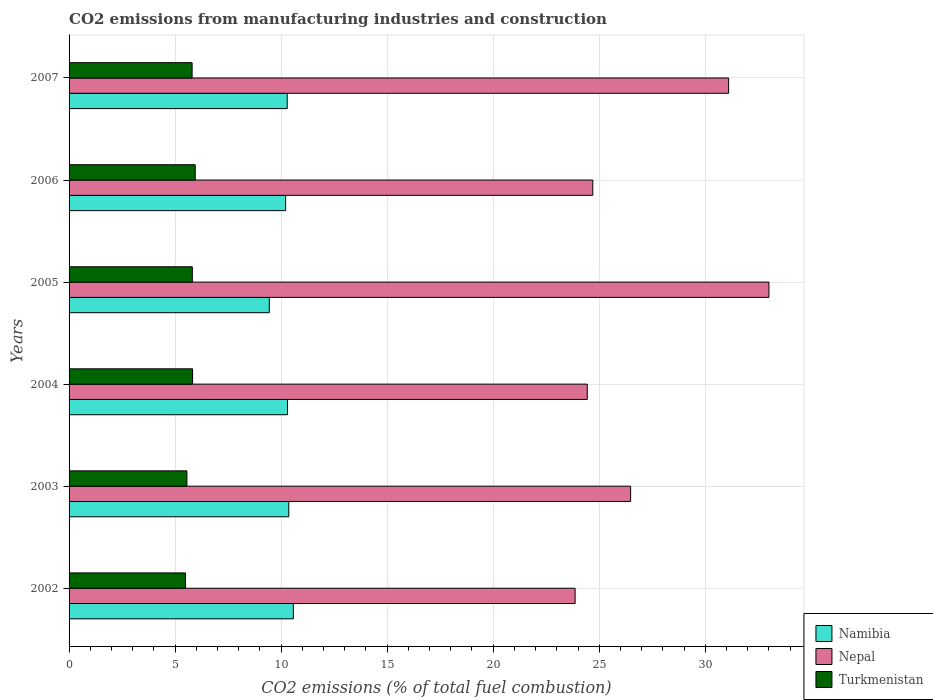Are the number of bars per tick equal to the number of legend labels?
Give a very brief answer. Yes. What is the label of the 4th group of bars from the top?
Your answer should be compact. 2004. What is the amount of CO2 emitted in Nepal in 2004?
Your answer should be compact. 24.44. Across all years, what is the maximum amount of CO2 emitted in Nepal?
Your answer should be compact. 33. Across all years, what is the minimum amount of CO2 emitted in Nepal?
Make the answer very short. 23.86. In which year was the amount of CO2 emitted in Namibia maximum?
Give a very brief answer. 2002. In which year was the amount of CO2 emitted in Nepal minimum?
Ensure brevity in your answer.  2002. What is the total amount of CO2 emitted in Turkmenistan in the graph?
Give a very brief answer. 34.44. What is the difference between the amount of CO2 emitted in Namibia in 2002 and that in 2004?
Give a very brief answer. 0.28. What is the difference between the amount of CO2 emitted in Turkmenistan in 2006 and the amount of CO2 emitted in Namibia in 2007?
Offer a terse response. -4.34. What is the average amount of CO2 emitted in Turkmenistan per year?
Give a very brief answer. 5.74. In the year 2002, what is the difference between the amount of CO2 emitted in Namibia and amount of CO2 emitted in Turkmenistan?
Your response must be concise. 5.08. What is the ratio of the amount of CO2 emitted in Namibia in 2004 to that in 2006?
Provide a succinct answer. 1.01. What is the difference between the highest and the second highest amount of CO2 emitted in Nepal?
Provide a succinct answer. 1.9. What is the difference between the highest and the lowest amount of CO2 emitted in Turkmenistan?
Your response must be concise. 0.46. What does the 1st bar from the top in 2005 represents?
Ensure brevity in your answer.  Turkmenistan. What does the 2nd bar from the bottom in 2003 represents?
Provide a succinct answer. Nepal. Is it the case that in every year, the sum of the amount of CO2 emitted in Turkmenistan and amount of CO2 emitted in Nepal is greater than the amount of CO2 emitted in Namibia?
Provide a short and direct response. Yes. Are all the bars in the graph horizontal?
Provide a short and direct response. Yes. How many years are there in the graph?
Keep it short and to the point. 6. What is the difference between two consecutive major ticks on the X-axis?
Give a very brief answer. 5. Are the values on the major ticks of X-axis written in scientific E-notation?
Provide a succinct answer. No. Does the graph contain grids?
Offer a very short reply. Yes. Where does the legend appear in the graph?
Your answer should be very brief. Bottom right. What is the title of the graph?
Provide a short and direct response. CO2 emissions from manufacturing industries and construction. Does "Monaco" appear as one of the legend labels in the graph?
Give a very brief answer. No. What is the label or title of the X-axis?
Your answer should be compact. CO2 emissions (% of total fuel combustion). What is the CO2 emissions (% of total fuel combustion) in Namibia in 2002?
Offer a very short reply. 10.58. What is the CO2 emissions (% of total fuel combustion) of Nepal in 2002?
Give a very brief answer. 23.86. What is the CO2 emissions (% of total fuel combustion) of Turkmenistan in 2002?
Give a very brief answer. 5.49. What is the CO2 emissions (% of total fuel combustion) in Namibia in 2003?
Make the answer very short. 10.36. What is the CO2 emissions (% of total fuel combustion) in Nepal in 2003?
Your response must be concise. 26.48. What is the CO2 emissions (% of total fuel combustion) in Turkmenistan in 2003?
Your response must be concise. 5.56. What is the CO2 emissions (% of total fuel combustion) in Namibia in 2004?
Provide a short and direct response. 10.3. What is the CO2 emissions (% of total fuel combustion) of Nepal in 2004?
Provide a short and direct response. 24.44. What is the CO2 emissions (% of total fuel combustion) in Turkmenistan in 2004?
Your answer should be very brief. 5.82. What is the CO2 emissions (% of total fuel combustion) of Namibia in 2005?
Offer a terse response. 9.44. What is the CO2 emissions (% of total fuel combustion) in Nepal in 2005?
Ensure brevity in your answer.  33. What is the CO2 emissions (% of total fuel combustion) of Turkmenistan in 2005?
Offer a terse response. 5.81. What is the CO2 emissions (% of total fuel combustion) in Namibia in 2006?
Ensure brevity in your answer.  10.21. What is the CO2 emissions (% of total fuel combustion) in Nepal in 2006?
Make the answer very short. 24.7. What is the CO2 emissions (% of total fuel combustion) of Turkmenistan in 2006?
Provide a short and direct response. 5.95. What is the CO2 emissions (% of total fuel combustion) of Namibia in 2007?
Offer a very short reply. 10.29. What is the CO2 emissions (% of total fuel combustion) of Nepal in 2007?
Your response must be concise. 31.1. What is the CO2 emissions (% of total fuel combustion) of Turkmenistan in 2007?
Provide a succinct answer. 5.8. Across all years, what is the maximum CO2 emissions (% of total fuel combustion) in Namibia?
Offer a terse response. 10.58. Across all years, what is the maximum CO2 emissions (% of total fuel combustion) in Nepal?
Give a very brief answer. 33. Across all years, what is the maximum CO2 emissions (% of total fuel combustion) in Turkmenistan?
Provide a short and direct response. 5.95. Across all years, what is the minimum CO2 emissions (% of total fuel combustion) of Namibia?
Give a very brief answer. 9.44. Across all years, what is the minimum CO2 emissions (% of total fuel combustion) of Nepal?
Your answer should be compact. 23.86. Across all years, what is the minimum CO2 emissions (% of total fuel combustion) of Turkmenistan?
Make the answer very short. 5.49. What is the total CO2 emissions (% of total fuel combustion) in Namibia in the graph?
Your response must be concise. 61.18. What is the total CO2 emissions (% of total fuel combustion) in Nepal in the graph?
Keep it short and to the point. 163.58. What is the total CO2 emissions (% of total fuel combustion) of Turkmenistan in the graph?
Your response must be concise. 34.44. What is the difference between the CO2 emissions (% of total fuel combustion) of Namibia in 2002 and that in 2003?
Ensure brevity in your answer.  0.22. What is the difference between the CO2 emissions (% of total fuel combustion) in Nepal in 2002 and that in 2003?
Your response must be concise. -2.62. What is the difference between the CO2 emissions (% of total fuel combustion) of Turkmenistan in 2002 and that in 2003?
Offer a terse response. -0.06. What is the difference between the CO2 emissions (% of total fuel combustion) in Namibia in 2002 and that in 2004?
Offer a terse response. 0.28. What is the difference between the CO2 emissions (% of total fuel combustion) of Nepal in 2002 and that in 2004?
Give a very brief answer. -0.57. What is the difference between the CO2 emissions (% of total fuel combustion) of Turkmenistan in 2002 and that in 2004?
Give a very brief answer. -0.33. What is the difference between the CO2 emissions (% of total fuel combustion) in Namibia in 2002 and that in 2005?
Ensure brevity in your answer.  1.13. What is the difference between the CO2 emissions (% of total fuel combustion) of Nepal in 2002 and that in 2005?
Your response must be concise. -9.14. What is the difference between the CO2 emissions (% of total fuel combustion) of Turkmenistan in 2002 and that in 2005?
Offer a very short reply. -0.32. What is the difference between the CO2 emissions (% of total fuel combustion) of Namibia in 2002 and that in 2006?
Give a very brief answer. 0.36. What is the difference between the CO2 emissions (% of total fuel combustion) of Nepal in 2002 and that in 2006?
Your answer should be compact. -0.83. What is the difference between the CO2 emissions (% of total fuel combustion) of Turkmenistan in 2002 and that in 2006?
Offer a very short reply. -0.46. What is the difference between the CO2 emissions (% of total fuel combustion) in Namibia in 2002 and that in 2007?
Your response must be concise. 0.29. What is the difference between the CO2 emissions (% of total fuel combustion) in Nepal in 2002 and that in 2007?
Give a very brief answer. -7.24. What is the difference between the CO2 emissions (% of total fuel combustion) of Turkmenistan in 2002 and that in 2007?
Provide a succinct answer. -0.31. What is the difference between the CO2 emissions (% of total fuel combustion) in Namibia in 2003 and that in 2004?
Your answer should be very brief. 0.06. What is the difference between the CO2 emissions (% of total fuel combustion) in Nepal in 2003 and that in 2004?
Provide a succinct answer. 2.04. What is the difference between the CO2 emissions (% of total fuel combustion) of Turkmenistan in 2003 and that in 2004?
Ensure brevity in your answer.  -0.27. What is the difference between the CO2 emissions (% of total fuel combustion) in Namibia in 2003 and that in 2005?
Provide a short and direct response. 0.92. What is the difference between the CO2 emissions (% of total fuel combustion) of Nepal in 2003 and that in 2005?
Your answer should be compact. -6.52. What is the difference between the CO2 emissions (% of total fuel combustion) of Turkmenistan in 2003 and that in 2005?
Your answer should be compact. -0.26. What is the difference between the CO2 emissions (% of total fuel combustion) in Namibia in 2003 and that in 2006?
Your answer should be very brief. 0.15. What is the difference between the CO2 emissions (% of total fuel combustion) of Nepal in 2003 and that in 2006?
Make the answer very short. 1.78. What is the difference between the CO2 emissions (% of total fuel combustion) of Turkmenistan in 2003 and that in 2006?
Offer a very short reply. -0.39. What is the difference between the CO2 emissions (% of total fuel combustion) of Namibia in 2003 and that in 2007?
Your answer should be compact. 0.07. What is the difference between the CO2 emissions (% of total fuel combustion) of Nepal in 2003 and that in 2007?
Keep it short and to the point. -4.62. What is the difference between the CO2 emissions (% of total fuel combustion) of Turkmenistan in 2003 and that in 2007?
Your answer should be very brief. -0.24. What is the difference between the CO2 emissions (% of total fuel combustion) of Namibia in 2004 and that in 2005?
Provide a succinct answer. 0.86. What is the difference between the CO2 emissions (% of total fuel combustion) of Nepal in 2004 and that in 2005?
Give a very brief answer. -8.57. What is the difference between the CO2 emissions (% of total fuel combustion) in Turkmenistan in 2004 and that in 2005?
Your response must be concise. 0.01. What is the difference between the CO2 emissions (% of total fuel combustion) of Namibia in 2004 and that in 2006?
Keep it short and to the point. 0.09. What is the difference between the CO2 emissions (% of total fuel combustion) of Nepal in 2004 and that in 2006?
Give a very brief answer. -0.26. What is the difference between the CO2 emissions (% of total fuel combustion) of Turkmenistan in 2004 and that in 2006?
Make the answer very short. -0.12. What is the difference between the CO2 emissions (% of total fuel combustion) in Namibia in 2004 and that in 2007?
Your response must be concise. 0.01. What is the difference between the CO2 emissions (% of total fuel combustion) in Nepal in 2004 and that in 2007?
Ensure brevity in your answer.  -6.67. What is the difference between the CO2 emissions (% of total fuel combustion) in Turkmenistan in 2004 and that in 2007?
Provide a short and direct response. 0.02. What is the difference between the CO2 emissions (% of total fuel combustion) in Namibia in 2005 and that in 2006?
Give a very brief answer. -0.77. What is the difference between the CO2 emissions (% of total fuel combustion) in Nepal in 2005 and that in 2006?
Keep it short and to the point. 8.31. What is the difference between the CO2 emissions (% of total fuel combustion) in Turkmenistan in 2005 and that in 2006?
Provide a succinct answer. -0.14. What is the difference between the CO2 emissions (% of total fuel combustion) in Namibia in 2005 and that in 2007?
Your response must be concise. -0.85. What is the difference between the CO2 emissions (% of total fuel combustion) of Nepal in 2005 and that in 2007?
Offer a very short reply. 1.9. What is the difference between the CO2 emissions (% of total fuel combustion) of Turkmenistan in 2005 and that in 2007?
Ensure brevity in your answer.  0.01. What is the difference between the CO2 emissions (% of total fuel combustion) of Namibia in 2006 and that in 2007?
Your response must be concise. -0.08. What is the difference between the CO2 emissions (% of total fuel combustion) in Nepal in 2006 and that in 2007?
Your answer should be very brief. -6.41. What is the difference between the CO2 emissions (% of total fuel combustion) in Turkmenistan in 2006 and that in 2007?
Your answer should be very brief. 0.15. What is the difference between the CO2 emissions (% of total fuel combustion) in Namibia in 2002 and the CO2 emissions (% of total fuel combustion) in Nepal in 2003?
Offer a very short reply. -15.9. What is the difference between the CO2 emissions (% of total fuel combustion) in Namibia in 2002 and the CO2 emissions (% of total fuel combustion) in Turkmenistan in 2003?
Give a very brief answer. 5.02. What is the difference between the CO2 emissions (% of total fuel combustion) of Nepal in 2002 and the CO2 emissions (% of total fuel combustion) of Turkmenistan in 2003?
Ensure brevity in your answer.  18.31. What is the difference between the CO2 emissions (% of total fuel combustion) of Namibia in 2002 and the CO2 emissions (% of total fuel combustion) of Nepal in 2004?
Your answer should be compact. -13.86. What is the difference between the CO2 emissions (% of total fuel combustion) in Namibia in 2002 and the CO2 emissions (% of total fuel combustion) in Turkmenistan in 2004?
Offer a very short reply. 4.75. What is the difference between the CO2 emissions (% of total fuel combustion) of Nepal in 2002 and the CO2 emissions (% of total fuel combustion) of Turkmenistan in 2004?
Provide a short and direct response. 18.04. What is the difference between the CO2 emissions (% of total fuel combustion) in Namibia in 2002 and the CO2 emissions (% of total fuel combustion) in Nepal in 2005?
Provide a succinct answer. -22.43. What is the difference between the CO2 emissions (% of total fuel combustion) in Namibia in 2002 and the CO2 emissions (% of total fuel combustion) in Turkmenistan in 2005?
Your answer should be very brief. 4.76. What is the difference between the CO2 emissions (% of total fuel combustion) of Nepal in 2002 and the CO2 emissions (% of total fuel combustion) of Turkmenistan in 2005?
Provide a short and direct response. 18.05. What is the difference between the CO2 emissions (% of total fuel combustion) of Namibia in 2002 and the CO2 emissions (% of total fuel combustion) of Nepal in 2006?
Offer a very short reply. -14.12. What is the difference between the CO2 emissions (% of total fuel combustion) of Namibia in 2002 and the CO2 emissions (% of total fuel combustion) of Turkmenistan in 2006?
Provide a short and direct response. 4.63. What is the difference between the CO2 emissions (% of total fuel combustion) in Nepal in 2002 and the CO2 emissions (% of total fuel combustion) in Turkmenistan in 2006?
Keep it short and to the point. 17.92. What is the difference between the CO2 emissions (% of total fuel combustion) in Namibia in 2002 and the CO2 emissions (% of total fuel combustion) in Nepal in 2007?
Your answer should be compact. -20.53. What is the difference between the CO2 emissions (% of total fuel combustion) in Namibia in 2002 and the CO2 emissions (% of total fuel combustion) in Turkmenistan in 2007?
Give a very brief answer. 4.78. What is the difference between the CO2 emissions (% of total fuel combustion) in Nepal in 2002 and the CO2 emissions (% of total fuel combustion) in Turkmenistan in 2007?
Keep it short and to the point. 18.06. What is the difference between the CO2 emissions (% of total fuel combustion) of Namibia in 2003 and the CO2 emissions (% of total fuel combustion) of Nepal in 2004?
Offer a very short reply. -14.08. What is the difference between the CO2 emissions (% of total fuel combustion) of Namibia in 2003 and the CO2 emissions (% of total fuel combustion) of Turkmenistan in 2004?
Offer a very short reply. 4.54. What is the difference between the CO2 emissions (% of total fuel combustion) of Nepal in 2003 and the CO2 emissions (% of total fuel combustion) of Turkmenistan in 2004?
Your response must be concise. 20.66. What is the difference between the CO2 emissions (% of total fuel combustion) of Namibia in 2003 and the CO2 emissions (% of total fuel combustion) of Nepal in 2005?
Keep it short and to the point. -22.64. What is the difference between the CO2 emissions (% of total fuel combustion) of Namibia in 2003 and the CO2 emissions (% of total fuel combustion) of Turkmenistan in 2005?
Your answer should be compact. 4.55. What is the difference between the CO2 emissions (% of total fuel combustion) of Nepal in 2003 and the CO2 emissions (% of total fuel combustion) of Turkmenistan in 2005?
Your response must be concise. 20.67. What is the difference between the CO2 emissions (% of total fuel combustion) of Namibia in 2003 and the CO2 emissions (% of total fuel combustion) of Nepal in 2006?
Keep it short and to the point. -14.34. What is the difference between the CO2 emissions (% of total fuel combustion) in Namibia in 2003 and the CO2 emissions (% of total fuel combustion) in Turkmenistan in 2006?
Offer a terse response. 4.41. What is the difference between the CO2 emissions (% of total fuel combustion) of Nepal in 2003 and the CO2 emissions (% of total fuel combustion) of Turkmenistan in 2006?
Make the answer very short. 20.53. What is the difference between the CO2 emissions (% of total fuel combustion) in Namibia in 2003 and the CO2 emissions (% of total fuel combustion) in Nepal in 2007?
Give a very brief answer. -20.74. What is the difference between the CO2 emissions (% of total fuel combustion) in Namibia in 2003 and the CO2 emissions (% of total fuel combustion) in Turkmenistan in 2007?
Keep it short and to the point. 4.56. What is the difference between the CO2 emissions (% of total fuel combustion) in Nepal in 2003 and the CO2 emissions (% of total fuel combustion) in Turkmenistan in 2007?
Your answer should be compact. 20.68. What is the difference between the CO2 emissions (% of total fuel combustion) in Namibia in 2004 and the CO2 emissions (% of total fuel combustion) in Nepal in 2005?
Provide a succinct answer. -22.7. What is the difference between the CO2 emissions (% of total fuel combustion) of Namibia in 2004 and the CO2 emissions (% of total fuel combustion) of Turkmenistan in 2005?
Your response must be concise. 4.49. What is the difference between the CO2 emissions (% of total fuel combustion) in Nepal in 2004 and the CO2 emissions (% of total fuel combustion) in Turkmenistan in 2005?
Your response must be concise. 18.62. What is the difference between the CO2 emissions (% of total fuel combustion) in Namibia in 2004 and the CO2 emissions (% of total fuel combustion) in Nepal in 2006?
Your answer should be compact. -14.4. What is the difference between the CO2 emissions (% of total fuel combustion) in Namibia in 2004 and the CO2 emissions (% of total fuel combustion) in Turkmenistan in 2006?
Your answer should be very brief. 4.35. What is the difference between the CO2 emissions (% of total fuel combustion) in Nepal in 2004 and the CO2 emissions (% of total fuel combustion) in Turkmenistan in 2006?
Ensure brevity in your answer.  18.49. What is the difference between the CO2 emissions (% of total fuel combustion) in Namibia in 2004 and the CO2 emissions (% of total fuel combustion) in Nepal in 2007?
Give a very brief answer. -20.8. What is the difference between the CO2 emissions (% of total fuel combustion) in Namibia in 2004 and the CO2 emissions (% of total fuel combustion) in Turkmenistan in 2007?
Offer a terse response. 4.5. What is the difference between the CO2 emissions (% of total fuel combustion) of Nepal in 2004 and the CO2 emissions (% of total fuel combustion) of Turkmenistan in 2007?
Your answer should be compact. 18.63. What is the difference between the CO2 emissions (% of total fuel combustion) in Namibia in 2005 and the CO2 emissions (% of total fuel combustion) in Nepal in 2006?
Ensure brevity in your answer.  -15.25. What is the difference between the CO2 emissions (% of total fuel combustion) of Namibia in 2005 and the CO2 emissions (% of total fuel combustion) of Turkmenistan in 2006?
Make the answer very short. 3.49. What is the difference between the CO2 emissions (% of total fuel combustion) of Nepal in 2005 and the CO2 emissions (% of total fuel combustion) of Turkmenistan in 2006?
Your answer should be very brief. 27.05. What is the difference between the CO2 emissions (% of total fuel combustion) of Namibia in 2005 and the CO2 emissions (% of total fuel combustion) of Nepal in 2007?
Offer a terse response. -21.66. What is the difference between the CO2 emissions (% of total fuel combustion) of Namibia in 2005 and the CO2 emissions (% of total fuel combustion) of Turkmenistan in 2007?
Offer a very short reply. 3.64. What is the difference between the CO2 emissions (% of total fuel combustion) of Nepal in 2005 and the CO2 emissions (% of total fuel combustion) of Turkmenistan in 2007?
Offer a very short reply. 27.2. What is the difference between the CO2 emissions (% of total fuel combustion) in Namibia in 2006 and the CO2 emissions (% of total fuel combustion) in Nepal in 2007?
Give a very brief answer. -20.89. What is the difference between the CO2 emissions (% of total fuel combustion) in Namibia in 2006 and the CO2 emissions (% of total fuel combustion) in Turkmenistan in 2007?
Give a very brief answer. 4.41. What is the difference between the CO2 emissions (% of total fuel combustion) in Nepal in 2006 and the CO2 emissions (% of total fuel combustion) in Turkmenistan in 2007?
Offer a very short reply. 18.89. What is the average CO2 emissions (% of total fuel combustion) in Namibia per year?
Give a very brief answer. 10.2. What is the average CO2 emissions (% of total fuel combustion) of Nepal per year?
Give a very brief answer. 27.26. What is the average CO2 emissions (% of total fuel combustion) in Turkmenistan per year?
Ensure brevity in your answer.  5.74. In the year 2002, what is the difference between the CO2 emissions (% of total fuel combustion) of Namibia and CO2 emissions (% of total fuel combustion) of Nepal?
Make the answer very short. -13.29. In the year 2002, what is the difference between the CO2 emissions (% of total fuel combustion) of Namibia and CO2 emissions (% of total fuel combustion) of Turkmenistan?
Offer a very short reply. 5.08. In the year 2002, what is the difference between the CO2 emissions (% of total fuel combustion) in Nepal and CO2 emissions (% of total fuel combustion) in Turkmenistan?
Provide a short and direct response. 18.37. In the year 2003, what is the difference between the CO2 emissions (% of total fuel combustion) in Namibia and CO2 emissions (% of total fuel combustion) in Nepal?
Your answer should be very brief. -16.12. In the year 2003, what is the difference between the CO2 emissions (% of total fuel combustion) of Namibia and CO2 emissions (% of total fuel combustion) of Turkmenistan?
Offer a terse response. 4.8. In the year 2003, what is the difference between the CO2 emissions (% of total fuel combustion) of Nepal and CO2 emissions (% of total fuel combustion) of Turkmenistan?
Give a very brief answer. 20.92. In the year 2004, what is the difference between the CO2 emissions (% of total fuel combustion) in Namibia and CO2 emissions (% of total fuel combustion) in Nepal?
Your answer should be very brief. -14.14. In the year 2004, what is the difference between the CO2 emissions (% of total fuel combustion) of Namibia and CO2 emissions (% of total fuel combustion) of Turkmenistan?
Your answer should be very brief. 4.48. In the year 2004, what is the difference between the CO2 emissions (% of total fuel combustion) of Nepal and CO2 emissions (% of total fuel combustion) of Turkmenistan?
Your answer should be compact. 18.61. In the year 2005, what is the difference between the CO2 emissions (% of total fuel combustion) of Namibia and CO2 emissions (% of total fuel combustion) of Nepal?
Your answer should be very brief. -23.56. In the year 2005, what is the difference between the CO2 emissions (% of total fuel combustion) in Namibia and CO2 emissions (% of total fuel combustion) in Turkmenistan?
Your answer should be compact. 3.63. In the year 2005, what is the difference between the CO2 emissions (% of total fuel combustion) in Nepal and CO2 emissions (% of total fuel combustion) in Turkmenistan?
Offer a very short reply. 27.19. In the year 2006, what is the difference between the CO2 emissions (% of total fuel combustion) in Namibia and CO2 emissions (% of total fuel combustion) in Nepal?
Offer a very short reply. -14.48. In the year 2006, what is the difference between the CO2 emissions (% of total fuel combustion) of Namibia and CO2 emissions (% of total fuel combustion) of Turkmenistan?
Provide a succinct answer. 4.26. In the year 2006, what is the difference between the CO2 emissions (% of total fuel combustion) of Nepal and CO2 emissions (% of total fuel combustion) of Turkmenistan?
Your response must be concise. 18.75. In the year 2007, what is the difference between the CO2 emissions (% of total fuel combustion) of Namibia and CO2 emissions (% of total fuel combustion) of Nepal?
Your answer should be compact. -20.81. In the year 2007, what is the difference between the CO2 emissions (% of total fuel combustion) in Namibia and CO2 emissions (% of total fuel combustion) in Turkmenistan?
Keep it short and to the point. 4.49. In the year 2007, what is the difference between the CO2 emissions (% of total fuel combustion) of Nepal and CO2 emissions (% of total fuel combustion) of Turkmenistan?
Make the answer very short. 25.3. What is the ratio of the CO2 emissions (% of total fuel combustion) in Namibia in 2002 to that in 2003?
Provide a succinct answer. 1.02. What is the ratio of the CO2 emissions (% of total fuel combustion) in Nepal in 2002 to that in 2003?
Ensure brevity in your answer.  0.9. What is the ratio of the CO2 emissions (% of total fuel combustion) of Turkmenistan in 2002 to that in 2003?
Provide a succinct answer. 0.99. What is the ratio of the CO2 emissions (% of total fuel combustion) of Namibia in 2002 to that in 2004?
Your answer should be compact. 1.03. What is the ratio of the CO2 emissions (% of total fuel combustion) of Nepal in 2002 to that in 2004?
Ensure brevity in your answer.  0.98. What is the ratio of the CO2 emissions (% of total fuel combustion) in Turkmenistan in 2002 to that in 2004?
Your response must be concise. 0.94. What is the ratio of the CO2 emissions (% of total fuel combustion) of Namibia in 2002 to that in 2005?
Your answer should be compact. 1.12. What is the ratio of the CO2 emissions (% of total fuel combustion) of Nepal in 2002 to that in 2005?
Provide a short and direct response. 0.72. What is the ratio of the CO2 emissions (% of total fuel combustion) of Turkmenistan in 2002 to that in 2005?
Keep it short and to the point. 0.94. What is the ratio of the CO2 emissions (% of total fuel combustion) of Namibia in 2002 to that in 2006?
Your answer should be very brief. 1.04. What is the ratio of the CO2 emissions (% of total fuel combustion) in Nepal in 2002 to that in 2006?
Offer a terse response. 0.97. What is the ratio of the CO2 emissions (% of total fuel combustion) in Turkmenistan in 2002 to that in 2006?
Your answer should be very brief. 0.92. What is the ratio of the CO2 emissions (% of total fuel combustion) in Namibia in 2002 to that in 2007?
Your answer should be compact. 1.03. What is the ratio of the CO2 emissions (% of total fuel combustion) of Nepal in 2002 to that in 2007?
Make the answer very short. 0.77. What is the ratio of the CO2 emissions (% of total fuel combustion) of Turkmenistan in 2002 to that in 2007?
Make the answer very short. 0.95. What is the ratio of the CO2 emissions (% of total fuel combustion) in Nepal in 2003 to that in 2004?
Offer a terse response. 1.08. What is the ratio of the CO2 emissions (% of total fuel combustion) in Turkmenistan in 2003 to that in 2004?
Your answer should be very brief. 0.95. What is the ratio of the CO2 emissions (% of total fuel combustion) in Namibia in 2003 to that in 2005?
Your answer should be very brief. 1.1. What is the ratio of the CO2 emissions (% of total fuel combustion) in Nepal in 2003 to that in 2005?
Provide a succinct answer. 0.8. What is the ratio of the CO2 emissions (% of total fuel combustion) in Turkmenistan in 2003 to that in 2005?
Your answer should be compact. 0.96. What is the ratio of the CO2 emissions (% of total fuel combustion) in Namibia in 2003 to that in 2006?
Offer a terse response. 1.01. What is the ratio of the CO2 emissions (% of total fuel combustion) in Nepal in 2003 to that in 2006?
Your answer should be compact. 1.07. What is the ratio of the CO2 emissions (% of total fuel combustion) of Turkmenistan in 2003 to that in 2006?
Ensure brevity in your answer.  0.93. What is the ratio of the CO2 emissions (% of total fuel combustion) of Nepal in 2003 to that in 2007?
Your response must be concise. 0.85. What is the ratio of the CO2 emissions (% of total fuel combustion) of Turkmenistan in 2003 to that in 2007?
Your answer should be very brief. 0.96. What is the ratio of the CO2 emissions (% of total fuel combustion) in Namibia in 2004 to that in 2005?
Provide a short and direct response. 1.09. What is the ratio of the CO2 emissions (% of total fuel combustion) of Nepal in 2004 to that in 2005?
Offer a terse response. 0.74. What is the ratio of the CO2 emissions (% of total fuel combustion) in Turkmenistan in 2004 to that in 2005?
Provide a succinct answer. 1. What is the ratio of the CO2 emissions (% of total fuel combustion) in Namibia in 2004 to that in 2006?
Make the answer very short. 1.01. What is the ratio of the CO2 emissions (% of total fuel combustion) in Nepal in 2004 to that in 2006?
Ensure brevity in your answer.  0.99. What is the ratio of the CO2 emissions (% of total fuel combustion) of Turkmenistan in 2004 to that in 2006?
Keep it short and to the point. 0.98. What is the ratio of the CO2 emissions (% of total fuel combustion) in Nepal in 2004 to that in 2007?
Provide a succinct answer. 0.79. What is the ratio of the CO2 emissions (% of total fuel combustion) in Namibia in 2005 to that in 2006?
Give a very brief answer. 0.92. What is the ratio of the CO2 emissions (% of total fuel combustion) of Nepal in 2005 to that in 2006?
Give a very brief answer. 1.34. What is the ratio of the CO2 emissions (% of total fuel combustion) of Turkmenistan in 2005 to that in 2006?
Ensure brevity in your answer.  0.98. What is the ratio of the CO2 emissions (% of total fuel combustion) of Namibia in 2005 to that in 2007?
Offer a terse response. 0.92. What is the ratio of the CO2 emissions (% of total fuel combustion) of Nepal in 2005 to that in 2007?
Provide a succinct answer. 1.06. What is the ratio of the CO2 emissions (% of total fuel combustion) of Turkmenistan in 2005 to that in 2007?
Offer a very short reply. 1. What is the ratio of the CO2 emissions (% of total fuel combustion) of Nepal in 2006 to that in 2007?
Provide a short and direct response. 0.79. What is the ratio of the CO2 emissions (% of total fuel combustion) of Turkmenistan in 2006 to that in 2007?
Ensure brevity in your answer.  1.03. What is the difference between the highest and the second highest CO2 emissions (% of total fuel combustion) in Namibia?
Give a very brief answer. 0.22. What is the difference between the highest and the second highest CO2 emissions (% of total fuel combustion) in Nepal?
Offer a very short reply. 1.9. What is the difference between the highest and the second highest CO2 emissions (% of total fuel combustion) in Turkmenistan?
Ensure brevity in your answer.  0.12. What is the difference between the highest and the lowest CO2 emissions (% of total fuel combustion) in Namibia?
Your response must be concise. 1.13. What is the difference between the highest and the lowest CO2 emissions (% of total fuel combustion) of Nepal?
Make the answer very short. 9.14. What is the difference between the highest and the lowest CO2 emissions (% of total fuel combustion) in Turkmenistan?
Ensure brevity in your answer.  0.46. 